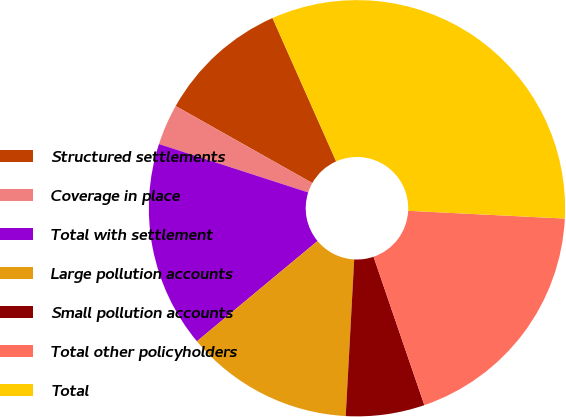Convert chart. <chart><loc_0><loc_0><loc_500><loc_500><pie_chart><fcel>Structured settlements<fcel>Coverage in place<fcel>Total with settlement<fcel>Large pollution accounts<fcel>Small pollution accounts<fcel>Total other policyholders<fcel>Total<nl><fcel>10.18%<fcel>3.18%<fcel>16.03%<fcel>13.1%<fcel>6.11%<fcel>18.96%<fcel>32.44%<nl></chart> 